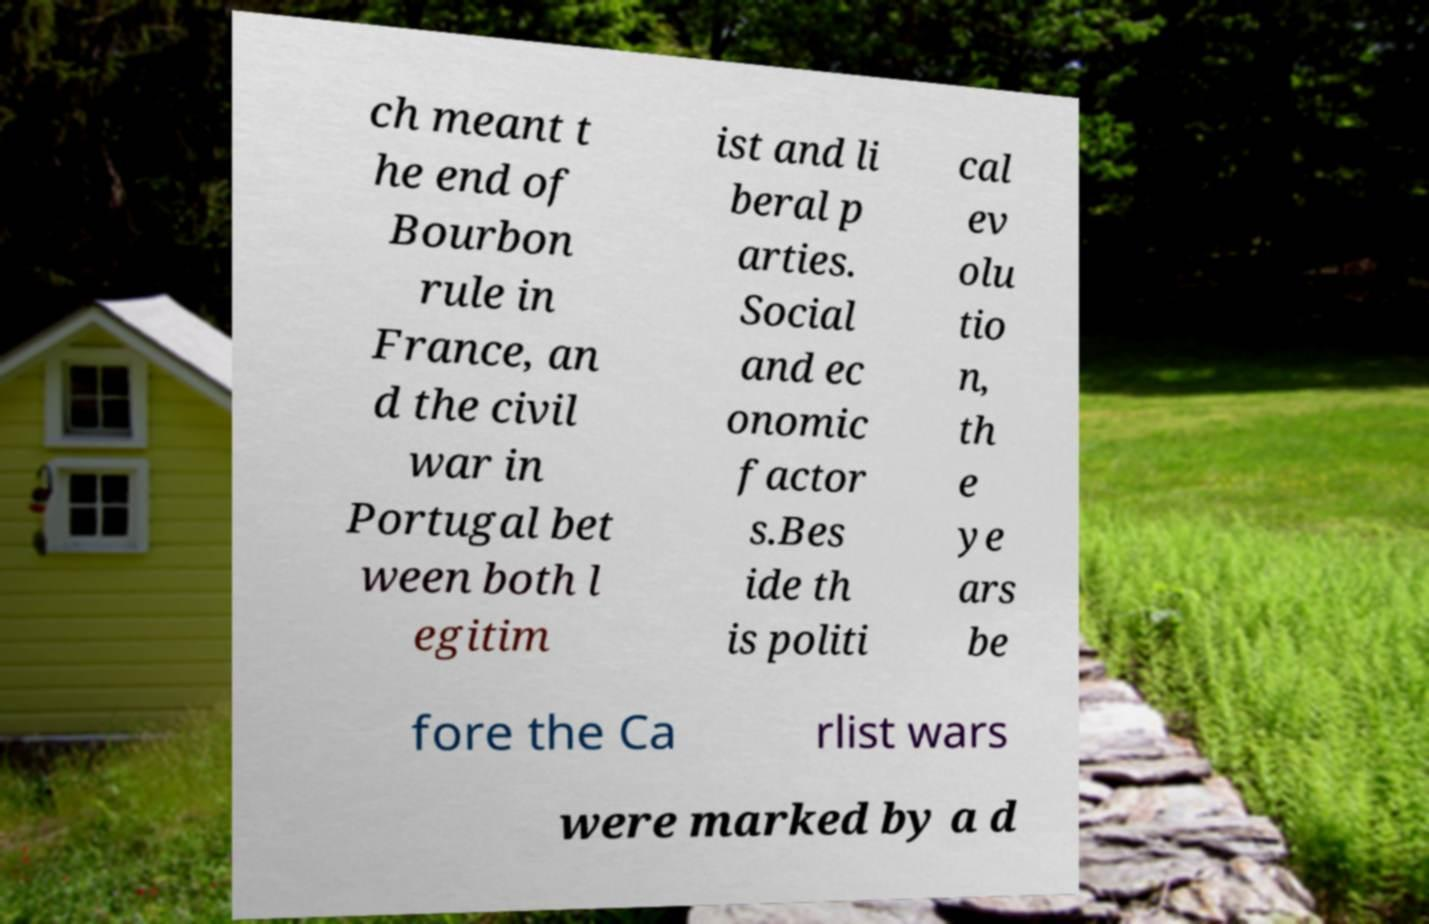For documentation purposes, I need the text within this image transcribed. Could you provide that? ch meant t he end of Bourbon rule in France, an d the civil war in Portugal bet ween both l egitim ist and li beral p arties. Social and ec onomic factor s.Bes ide th is politi cal ev olu tio n, th e ye ars be fore the Ca rlist wars were marked by a d 